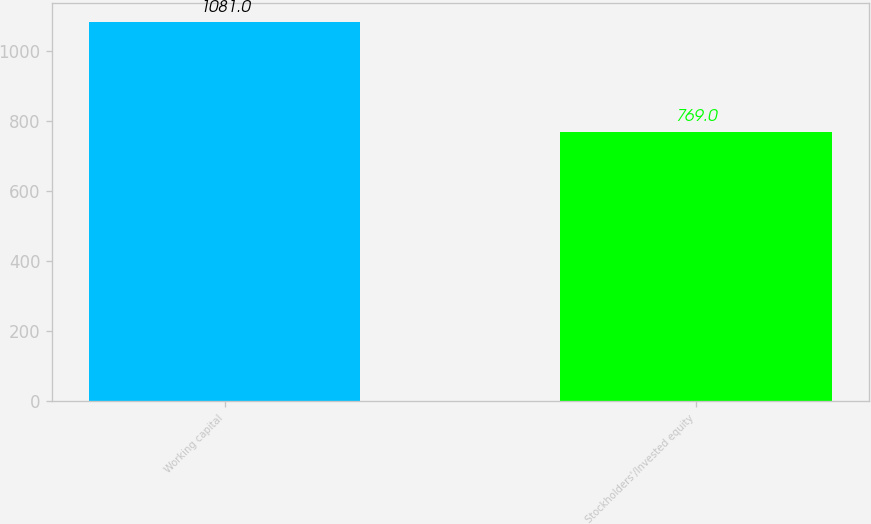Convert chart to OTSL. <chart><loc_0><loc_0><loc_500><loc_500><bar_chart><fcel>Working capital<fcel>Stockholders'/Invested equity<nl><fcel>1081<fcel>769<nl></chart> 